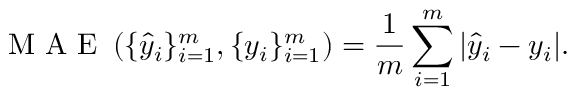<formula> <loc_0><loc_0><loc_500><loc_500>M A E \left ( \{ \hat { y } _ { i } \} _ { i = 1 } ^ { m } , \{ y _ { i } \} _ { i = 1 } ^ { m } \right ) = \frac { 1 } { m } \sum _ { i = 1 } ^ { m } | \hat { y } _ { i } - y _ { i } | .</formula> 